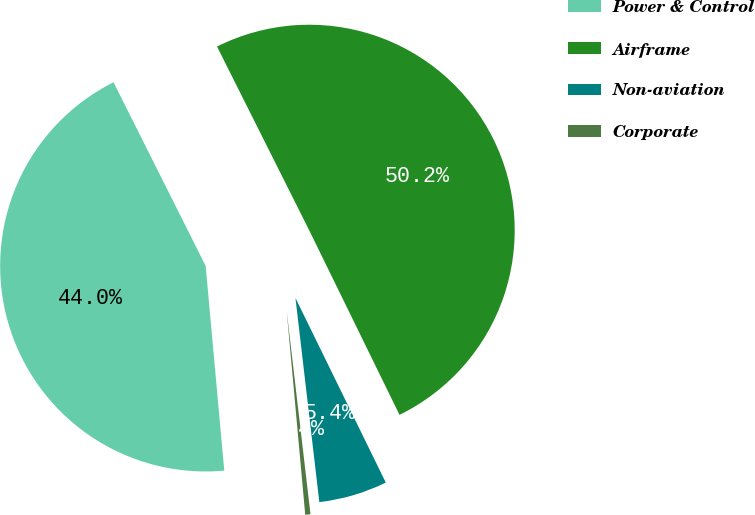<chart> <loc_0><loc_0><loc_500><loc_500><pie_chart><fcel>Power & Control<fcel>Airframe<fcel>Non-aviation<fcel>Corporate<nl><fcel>44.04%<fcel>50.15%<fcel>5.39%<fcel>0.41%<nl></chart> 